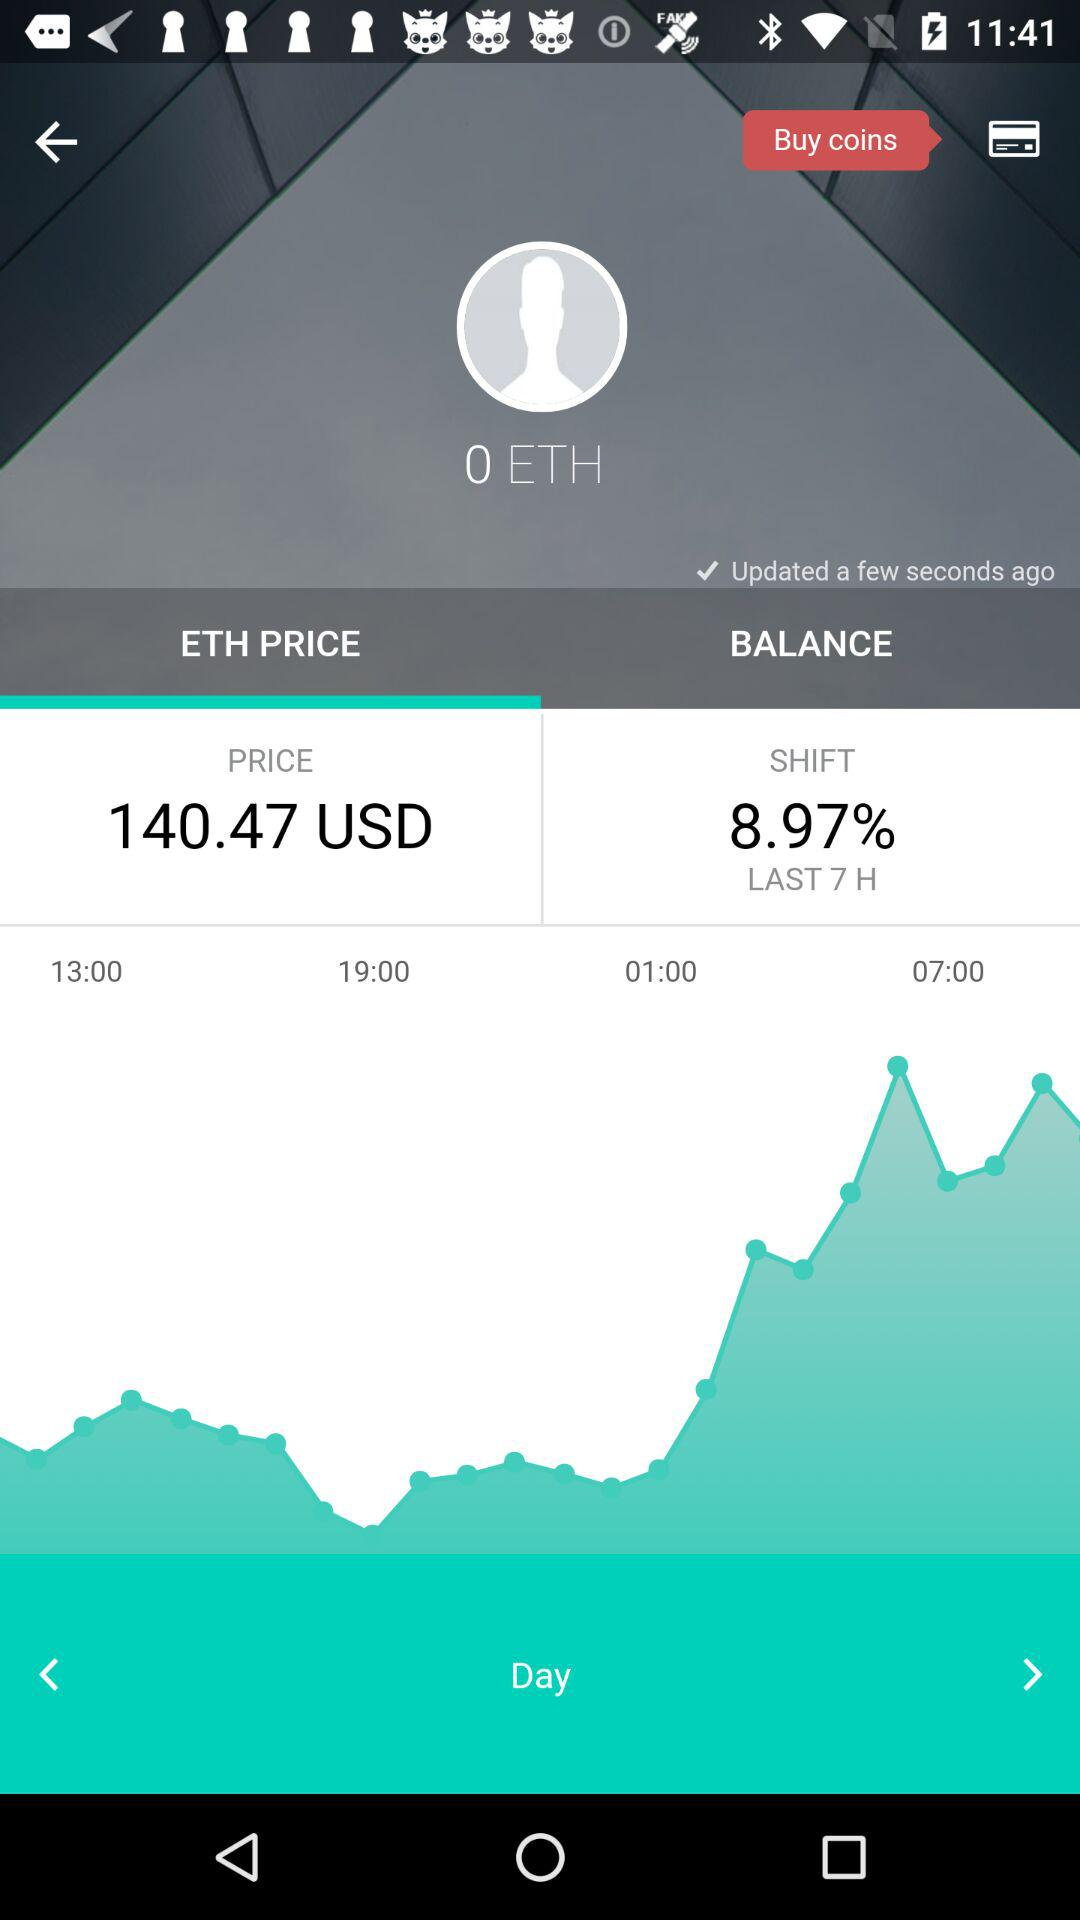What is the shift percentage? The shift percentage is 8.97. 